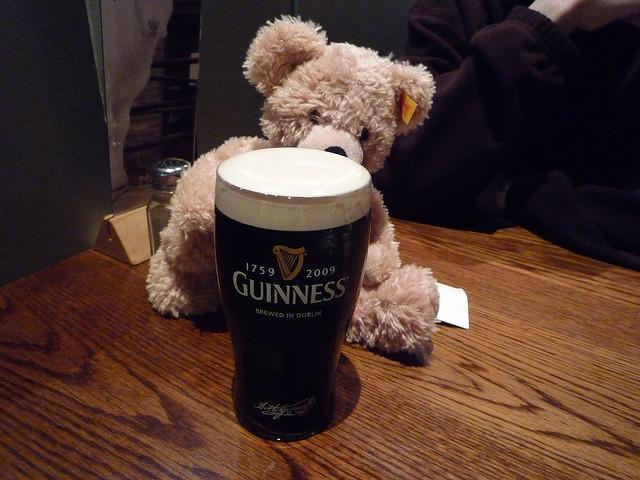Is the caption "The teddy bear is in the middle of the dining table." a true representation of the image?
Answer yes or no. No. Is the caption "The teddy bear is off the dining table." a true representation of the image?
Answer yes or no. No. Is the given caption "The teddy bear is touching the dining table." fitting for the image?
Answer yes or no. Yes. 